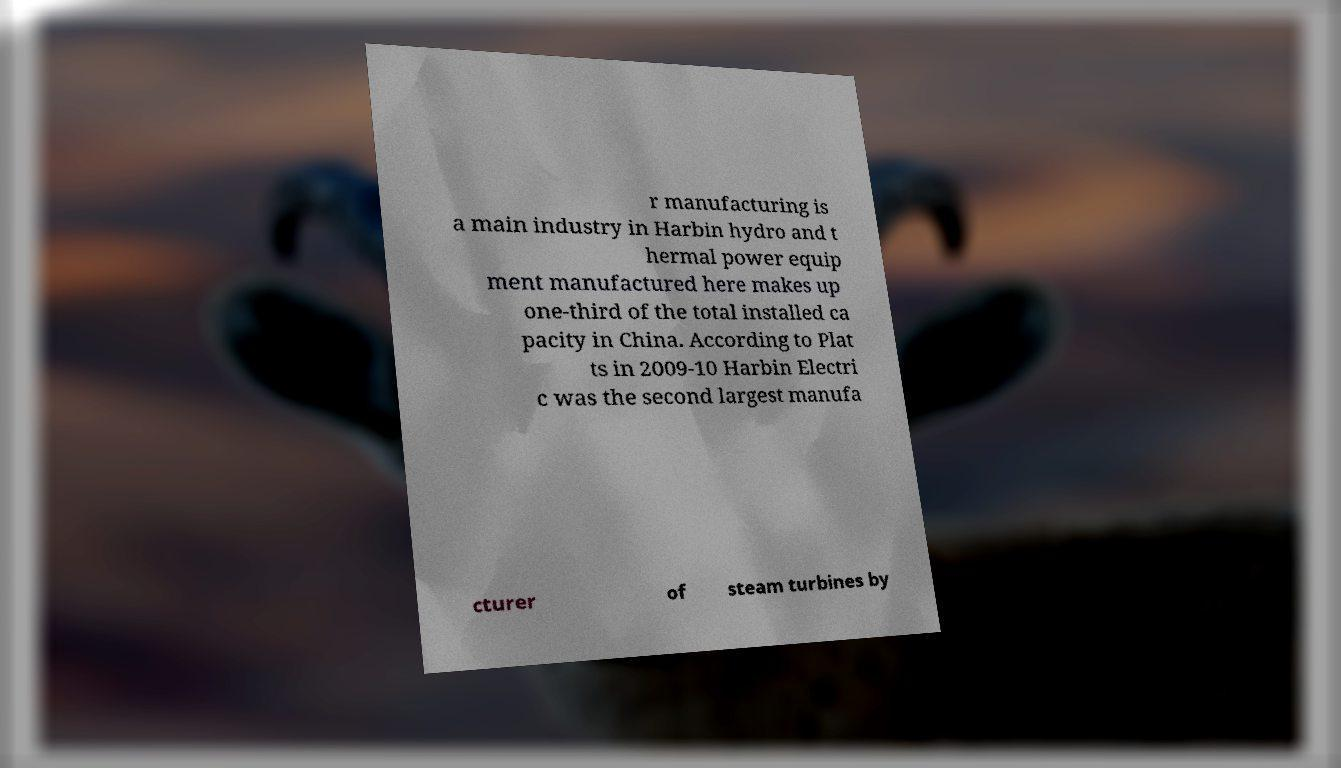Please identify and transcribe the text found in this image. r manufacturing is a main industry in Harbin hydro and t hermal power equip ment manufactured here makes up one-third of the total installed ca pacity in China. According to Plat ts in 2009-10 Harbin Electri c was the second largest manufa cturer of steam turbines by 